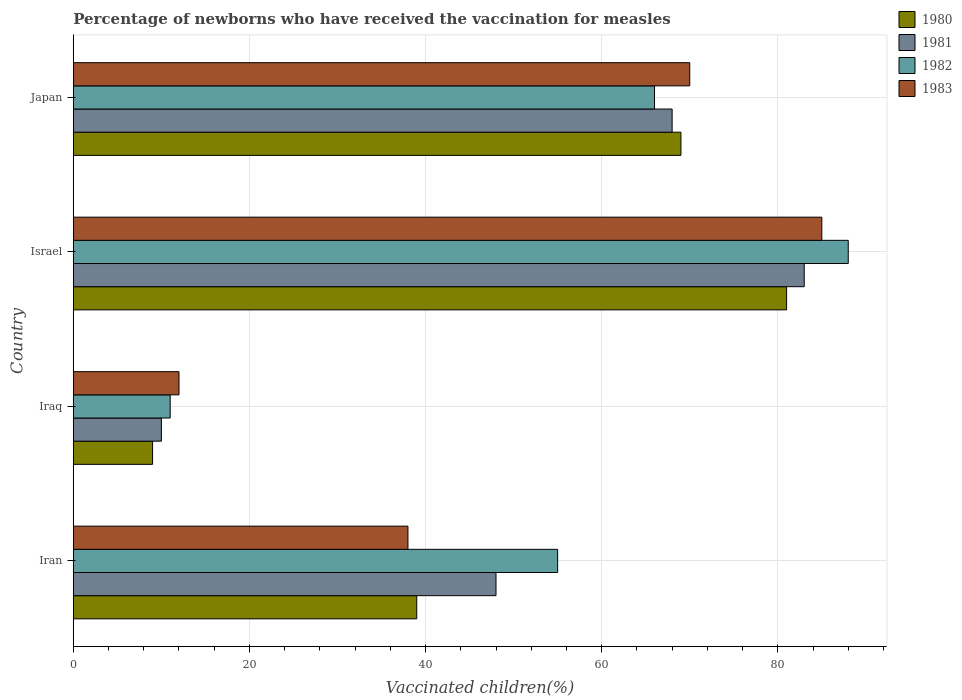How many groups of bars are there?
Your answer should be very brief. 4. Are the number of bars on each tick of the Y-axis equal?
Offer a very short reply. Yes. What is the label of the 4th group of bars from the top?
Provide a short and direct response. Iran. Across all countries, what is the maximum percentage of vaccinated children in 1983?
Provide a short and direct response. 85. In which country was the percentage of vaccinated children in 1983 minimum?
Your response must be concise. Iraq. What is the total percentage of vaccinated children in 1983 in the graph?
Your answer should be very brief. 205. What is the difference between the percentage of vaccinated children in 1980 in Japan and the percentage of vaccinated children in 1981 in Israel?
Make the answer very short. -14. What is the average percentage of vaccinated children in 1981 per country?
Give a very brief answer. 52.25. In how many countries, is the percentage of vaccinated children in 1983 greater than 4 %?
Offer a terse response. 4. What is the ratio of the percentage of vaccinated children in 1981 in Iraq to that in Israel?
Keep it short and to the point. 0.12. Is the difference between the percentage of vaccinated children in 1980 in Iraq and Japan greater than the difference between the percentage of vaccinated children in 1983 in Iraq and Japan?
Provide a succinct answer. No. What is the difference between the highest and the second highest percentage of vaccinated children in 1981?
Provide a short and direct response. 15. What is the difference between the highest and the lowest percentage of vaccinated children in 1983?
Your response must be concise. 73. Is the sum of the percentage of vaccinated children in 1981 in Iraq and Israel greater than the maximum percentage of vaccinated children in 1982 across all countries?
Keep it short and to the point. Yes. Is it the case that in every country, the sum of the percentage of vaccinated children in 1981 and percentage of vaccinated children in 1983 is greater than the sum of percentage of vaccinated children in 1982 and percentage of vaccinated children in 1980?
Provide a short and direct response. No. How many bars are there?
Provide a short and direct response. 16. Does the graph contain any zero values?
Offer a terse response. No. Does the graph contain grids?
Provide a short and direct response. Yes. Where does the legend appear in the graph?
Your answer should be compact. Top right. What is the title of the graph?
Offer a very short reply. Percentage of newborns who have received the vaccination for measles. Does "1991" appear as one of the legend labels in the graph?
Provide a short and direct response. No. What is the label or title of the X-axis?
Make the answer very short. Vaccinated children(%). What is the Vaccinated children(%) of 1980 in Iran?
Offer a very short reply. 39. What is the Vaccinated children(%) in 1981 in Iran?
Make the answer very short. 48. What is the Vaccinated children(%) of 1982 in Iraq?
Your answer should be compact. 11. What is the Vaccinated children(%) in 1982 in Israel?
Give a very brief answer. 88. What is the Vaccinated children(%) of 1983 in Israel?
Your answer should be compact. 85. What is the Vaccinated children(%) of 1980 in Japan?
Offer a very short reply. 69. What is the Vaccinated children(%) in 1981 in Japan?
Ensure brevity in your answer.  68. What is the Vaccinated children(%) in 1982 in Japan?
Offer a very short reply. 66. What is the Vaccinated children(%) in 1983 in Japan?
Make the answer very short. 70. Across all countries, what is the minimum Vaccinated children(%) of 1980?
Ensure brevity in your answer.  9. Across all countries, what is the minimum Vaccinated children(%) in 1981?
Provide a succinct answer. 10. Across all countries, what is the minimum Vaccinated children(%) in 1983?
Your answer should be compact. 12. What is the total Vaccinated children(%) of 1980 in the graph?
Offer a terse response. 198. What is the total Vaccinated children(%) of 1981 in the graph?
Ensure brevity in your answer.  209. What is the total Vaccinated children(%) of 1982 in the graph?
Your answer should be compact. 220. What is the total Vaccinated children(%) of 1983 in the graph?
Ensure brevity in your answer.  205. What is the difference between the Vaccinated children(%) of 1982 in Iran and that in Iraq?
Offer a very short reply. 44. What is the difference between the Vaccinated children(%) in 1980 in Iran and that in Israel?
Offer a very short reply. -42. What is the difference between the Vaccinated children(%) in 1981 in Iran and that in Israel?
Give a very brief answer. -35. What is the difference between the Vaccinated children(%) of 1982 in Iran and that in Israel?
Offer a very short reply. -33. What is the difference between the Vaccinated children(%) of 1983 in Iran and that in Israel?
Provide a short and direct response. -47. What is the difference between the Vaccinated children(%) in 1980 in Iran and that in Japan?
Your answer should be compact. -30. What is the difference between the Vaccinated children(%) of 1982 in Iran and that in Japan?
Offer a terse response. -11. What is the difference between the Vaccinated children(%) in 1983 in Iran and that in Japan?
Ensure brevity in your answer.  -32. What is the difference between the Vaccinated children(%) of 1980 in Iraq and that in Israel?
Give a very brief answer. -72. What is the difference between the Vaccinated children(%) in 1981 in Iraq and that in Israel?
Keep it short and to the point. -73. What is the difference between the Vaccinated children(%) of 1982 in Iraq and that in Israel?
Provide a succinct answer. -77. What is the difference between the Vaccinated children(%) in 1983 in Iraq and that in Israel?
Provide a succinct answer. -73. What is the difference between the Vaccinated children(%) in 1980 in Iraq and that in Japan?
Give a very brief answer. -60. What is the difference between the Vaccinated children(%) in 1981 in Iraq and that in Japan?
Your answer should be compact. -58. What is the difference between the Vaccinated children(%) in 1982 in Iraq and that in Japan?
Make the answer very short. -55. What is the difference between the Vaccinated children(%) in 1983 in Iraq and that in Japan?
Your response must be concise. -58. What is the difference between the Vaccinated children(%) of 1980 in Israel and that in Japan?
Keep it short and to the point. 12. What is the difference between the Vaccinated children(%) of 1981 in Israel and that in Japan?
Give a very brief answer. 15. What is the difference between the Vaccinated children(%) of 1980 in Iran and the Vaccinated children(%) of 1982 in Iraq?
Your answer should be very brief. 28. What is the difference between the Vaccinated children(%) of 1981 in Iran and the Vaccinated children(%) of 1982 in Iraq?
Provide a short and direct response. 37. What is the difference between the Vaccinated children(%) of 1981 in Iran and the Vaccinated children(%) of 1983 in Iraq?
Your answer should be very brief. 36. What is the difference between the Vaccinated children(%) of 1980 in Iran and the Vaccinated children(%) of 1981 in Israel?
Offer a very short reply. -44. What is the difference between the Vaccinated children(%) in 1980 in Iran and the Vaccinated children(%) in 1982 in Israel?
Provide a succinct answer. -49. What is the difference between the Vaccinated children(%) in 1980 in Iran and the Vaccinated children(%) in 1983 in Israel?
Provide a succinct answer. -46. What is the difference between the Vaccinated children(%) of 1981 in Iran and the Vaccinated children(%) of 1983 in Israel?
Make the answer very short. -37. What is the difference between the Vaccinated children(%) of 1982 in Iran and the Vaccinated children(%) of 1983 in Israel?
Give a very brief answer. -30. What is the difference between the Vaccinated children(%) in 1980 in Iran and the Vaccinated children(%) in 1981 in Japan?
Your answer should be very brief. -29. What is the difference between the Vaccinated children(%) of 1980 in Iran and the Vaccinated children(%) of 1983 in Japan?
Your answer should be compact. -31. What is the difference between the Vaccinated children(%) in 1981 in Iran and the Vaccinated children(%) in 1982 in Japan?
Provide a short and direct response. -18. What is the difference between the Vaccinated children(%) in 1980 in Iraq and the Vaccinated children(%) in 1981 in Israel?
Your answer should be very brief. -74. What is the difference between the Vaccinated children(%) in 1980 in Iraq and the Vaccinated children(%) in 1982 in Israel?
Your answer should be compact. -79. What is the difference between the Vaccinated children(%) in 1980 in Iraq and the Vaccinated children(%) in 1983 in Israel?
Provide a short and direct response. -76. What is the difference between the Vaccinated children(%) in 1981 in Iraq and the Vaccinated children(%) in 1982 in Israel?
Ensure brevity in your answer.  -78. What is the difference between the Vaccinated children(%) in 1981 in Iraq and the Vaccinated children(%) in 1983 in Israel?
Your answer should be compact. -75. What is the difference between the Vaccinated children(%) of 1982 in Iraq and the Vaccinated children(%) of 1983 in Israel?
Your answer should be very brief. -74. What is the difference between the Vaccinated children(%) of 1980 in Iraq and the Vaccinated children(%) of 1981 in Japan?
Offer a terse response. -59. What is the difference between the Vaccinated children(%) in 1980 in Iraq and the Vaccinated children(%) in 1982 in Japan?
Your response must be concise. -57. What is the difference between the Vaccinated children(%) of 1980 in Iraq and the Vaccinated children(%) of 1983 in Japan?
Offer a very short reply. -61. What is the difference between the Vaccinated children(%) in 1981 in Iraq and the Vaccinated children(%) in 1982 in Japan?
Give a very brief answer. -56. What is the difference between the Vaccinated children(%) in 1981 in Iraq and the Vaccinated children(%) in 1983 in Japan?
Keep it short and to the point. -60. What is the difference between the Vaccinated children(%) in 1982 in Iraq and the Vaccinated children(%) in 1983 in Japan?
Your response must be concise. -59. What is the difference between the Vaccinated children(%) of 1981 in Israel and the Vaccinated children(%) of 1983 in Japan?
Make the answer very short. 13. What is the average Vaccinated children(%) in 1980 per country?
Make the answer very short. 49.5. What is the average Vaccinated children(%) in 1981 per country?
Your answer should be very brief. 52.25. What is the average Vaccinated children(%) in 1982 per country?
Your answer should be compact. 55. What is the average Vaccinated children(%) of 1983 per country?
Ensure brevity in your answer.  51.25. What is the difference between the Vaccinated children(%) in 1980 and Vaccinated children(%) in 1981 in Iran?
Provide a short and direct response. -9. What is the difference between the Vaccinated children(%) of 1980 and Vaccinated children(%) of 1982 in Iran?
Provide a short and direct response. -16. What is the difference between the Vaccinated children(%) in 1980 and Vaccinated children(%) in 1983 in Iran?
Provide a short and direct response. 1. What is the difference between the Vaccinated children(%) of 1981 and Vaccinated children(%) of 1982 in Iran?
Provide a succinct answer. -7. What is the difference between the Vaccinated children(%) of 1982 and Vaccinated children(%) of 1983 in Iran?
Your answer should be very brief. 17. What is the difference between the Vaccinated children(%) in 1980 and Vaccinated children(%) in 1981 in Iraq?
Make the answer very short. -1. What is the difference between the Vaccinated children(%) in 1980 and Vaccinated children(%) in 1982 in Iraq?
Provide a short and direct response. -2. What is the difference between the Vaccinated children(%) of 1980 and Vaccinated children(%) of 1983 in Iraq?
Ensure brevity in your answer.  -3. What is the difference between the Vaccinated children(%) in 1981 and Vaccinated children(%) in 1983 in Iraq?
Keep it short and to the point. -2. What is the difference between the Vaccinated children(%) in 1981 and Vaccinated children(%) in 1983 in Israel?
Your answer should be compact. -2. What is the difference between the Vaccinated children(%) of 1980 and Vaccinated children(%) of 1982 in Japan?
Offer a very short reply. 3. What is the difference between the Vaccinated children(%) of 1981 and Vaccinated children(%) of 1982 in Japan?
Offer a very short reply. 2. What is the ratio of the Vaccinated children(%) of 1980 in Iran to that in Iraq?
Give a very brief answer. 4.33. What is the ratio of the Vaccinated children(%) in 1981 in Iran to that in Iraq?
Ensure brevity in your answer.  4.8. What is the ratio of the Vaccinated children(%) in 1983 in Iran to that in Iraq?
Provide a succinct answer. 3.17. What is the ratio of the Vaccinated children(%) in 1980 in Iran to that in Israel?
Offer a very short reply. 0.48. What is the ratio of the Vaccinated children(%) in 1981 in Iran to that in Israel?
Give a very brief answer. 0.58. What is the ratio of the Vaccinated children(%) of 1983 in Iran to that in Israel?
Give a very brief answer. 0.45. What is the ratio of the Vaccinated children(%) in 1980 in Iran to that in Japan?
Your response must be concise. 0.57. What is the ratio of the Vaccinated children(%) of 1981 in Iran to that in Japan?
Offer a very short reply. 0.71. What is the ratio of the Vaccinated children(%) of 1982 in Iran to that in Japan?
Give a very brief answer. 0.83. What is the ratio of the Vaccinated children(%) in 1983 in Iran to that in Japan?
Make the answer very short. 0.54. What is the ratio of the Vaccinated children(%) in 1980 in Iraq to that in Israel?
Provide a succinct answer. 0.11. What is the ratio of the Vaccinated children(%) in 1981 in Iraq to that in Israel?
Provide a short and direct response. 0.12. What is the ratio of the Vaccinated children(%) of 1982 in Iraq to that in Israel?
Provide a succinct answer. 0.12. What is the ratio of the Vaccinated children(%) of 1983 in Iraq to that in Israel?
Offer a terse response. 0.14. What is the ratio of the Vaccinated children(%) of 1980 in Iraq to that in Japan?
Ensure brevity in your answer.  0.13. What is the ratio of the Vaccinated children(%) in 1981 in Iraq to that in Japan?
Offer a very short reply. 0.15. What is the ratio of the Vaccinated children(%) of 1982 in Iraq to that in Japan?
Give a very brief answer. 0.17. What is the ratio of the Vaccinated children(%) in 1983 in Iraq to that in Japan?
Your response must be concise. 0.17. What is the ratio of the Vaccinated children(%) in 1980 in Israel to that in Japan?
Provide a short and direct response. 1.17. What is the ratio of the Vaccinated children(%) of 1981 in Israel to that in Japan?
Provide a short and direct response. 1.22. What is the ratio of the Vaccinated children(%) of 1982 in Israel to that in Japan?
Provide a succinct answer. 1.33. What is the ratio of the Vaccinated children(%) in 1983 in Israel to that in Japan?
Offer a terse response. 1.21. What is the difference between the highest and the second highest Vaccinated children(%) of 1980?
Offer a terse response. 12. What is the difference between the highest and the second highest Vaccinated children(%) in 1981?
Ensure brevity in your answer.  15. What is the difference between the highest and the second highest Vaccinated children(%) of 1983?
Make the answer very short. 15. What is the difference between the highest and the lowest Vaccinated children(%) of 1980?
Give a very brief answer. 72. What is the difference between the highest and the lowest Vaccinated children(%) in 1981?
Provide a succinct answer. 73. What is the difference between the highest and the lowest Vaccinated children(%) of 1982?
Your answer should be compact. 77. What is the difference between the highest and the lowest Vaccinated children(%) of 1983?
Offer a terse response. 73. 